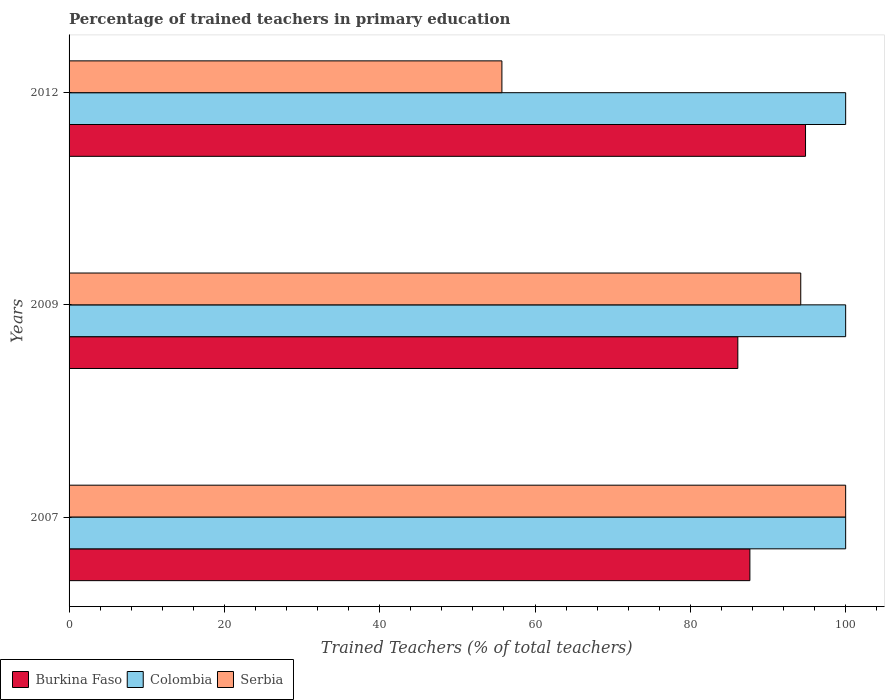Are the number of bars per tick equal to the number of legend labels?
Provide a succinct answer. Yes. How many bars are there on the 1st tick from the bottom?
Provide a succinct answer. 3. In how many cases, is the number of bars for a given year not equal to the number of legend labels?
Offer a very short reply. 0. What is the percentage of trained teachers in Serbia in 2012?
Provide a short and direct response. 55.73. Across all years, what is the minimum percentage of trained teachers in Serbia?
Offer a terse response. 55.73. In which year was the percentage of trained teachers in Burkina Faso maximum?
Offer a terse response. 2012. In which year was the percentage of trained teachers in Colombia minimum?
Make the answer very short. 2007. What is the total percentage of trained teachers in Colombia in the graph?
Make the answer very short. 300. What is the difference between the percentage of trained teachers in Colombia in 2009 and the percentage of trained teachers in Burkina Faso in 2012?
Offer a terse response. 5.17. What is the average percentage of trained teachers in Serbia per year?
Give a very brief answer. 83.32. In the year 2007, what is the difference between the percentage of trained teachers in Colombia and percentage of trained teachers in Burkina Faso?
Make the answer very short. 12.33. In how many years, is the percentage of trained teachers in Serbia greater than 52 %?
Your answer should be very brief. 3. What is the ratio of the percentage of trained teachers in Colombia in 2007 to that in 2012?
Your answer should be compact. 1. What is the difference between the highest and the second highest percentage of trained teachers in Burkina Faso?
Make the answer very short. 7.16. What is the difference between the highest and the lowest percentage of trained teachers in Colombia?
Provide a short and direct response. 0. In how many years, is the percentage of trained teachers in Burkina Faso greater than the average percentage of trained teachers in Burkina Faso taken over all years?
Keep it short and to the point. 1. What does the 1st bar from the top in 2012 represents?
Your answer should be compact. Serbia. What does the 2nd bar from the bottom in 2009 represents?
Your response must be concise. Colombia. How many bars are there?
Your answer should be compact. 9. How many years are there in the graph?
Keep it short and to the point. 3. Does the graph contain any zero values?
Your answer should be compact. No. How many legend labels are there?
Keep it short and to the point. 3. How are the legend labels stacked?
Ensure brevity in your answer.  Horizontal. What is the title of the graph?
Keep it short and to the point. Percentage of trained teachers in primary education. Does "Nepal" appear as one of the legend labels in the graph?
Offer a terse response. No. What is the label or title of the X-axis?
Your response must be concise. Trained Teachers (% of total teachers). What is the label or title of the Y-axis?
Provide a short and direct response. Years. What is the Trained Teachers (% of total teachers) in Burkina Faso in 2007?
Give a very brief answer. 87.67. What is the Trained Teachers (% of total teachers) of Serbia in 2007?
Keep it short and to the point. 100. What is the Trained Teachers (% of total teachers) of Burkina Faso in 2009?
Provide a short and direct response. 86.11. What is the Trained Teachers (% of total teachers) in Serbia in 2009?
Your response must be concise. 94.22. What is the Trained Teachers (% of total teachers) of Burkina Faso in 2012?
Your answer should be very brief. 94.83. What is the Trained Teachers (% of total teachers) of Colombia in 2012?
Keep it short and to the point. 100. What is the Trained Teachers (% of total teachers) of Serbia in 2012?
Your response must be concise. 55.73. Across all years, what is the maximum Trained Teachers (% of total teachers) in Burkina Faso?
Provide a succinct answer. 94.83. Across all years, what is the maximum Trained Teachers (% of total teachers) in Colombia?
Your answer should be compact. 100. Across all years, what is the maximum Trained Teachers (% of total teachers) of Serbia?
Ensure brevity in your answer.  100. Across all years, what is the minimum Trained Teachers (% of total teachers) in Burkina Faso?
Offer a terse response. 86.11. Across all years, what is the minimum Trained Teachers (% of total teachers) of Serbia?
Provide a short and direct response. 55.73. What is the total Trained Teachers (% of total teachers) in Burkina Faso in the graph?
Provide a succinct answer. 268.61. What is the total Trained Teachers (% of total teachers) of Colombia in the graph?
Ensure brevity in your answer.  300. What is the total Trained Teachers (% of total teachers) of Serbia in the graph?
Provide a short and direct response. 249.95. What is the difference between the Trained Teachers (% of total teachers) in Burkina Faso in 2007 and that in 2009?
Offer a terse response. 1.55. What is the difference between the Trained Teachers (% of total teachers) in Colombia in 2007 and that in 2009?
Your answer should be compact. 0. What is the difference between the Trained Teachers (% of total teachers) in Serbia in 2007 and that in 2009?
Your response must be concise. 5.78. What is the difference between the Trained Teachers (% of total teachers) in Burkina Faso in 2007 and that in 2012?
Your answer should be compact. -7.16. What is the difference between the Trained Teachers (% of total teachers) in Serbia in 2007 and that in 2012?
Provide a succinct answer. 44.27. What is the difference between the Trained Teachers (% of total teachers) of Burkina Faso in 2009 and that in 2012?
Make the answer very short. -8.72. What is the difference between the Trained Teachers (% of total teachers) of Serbia in 2009 and that in 2012?
Your response must be concise. 38.48. What is the difference between the Trained Teachers (% of total teachers) in Burkina Faso in 2007 and the Trained Teachers (% of total teachers) in Colombia in 2009?
Make the answer very short. -12.33. What is the difference between the Trained Teachers (% of total teachers) of Burkina Faso in 2007 and the Trained Teachers (% of total teachers) of Serbia in 2009?
Make the answer very short. -6.55. What is the difference between the Trained Teachers (% of total teachers) of Colombia in 2007 and the Trained Teachers (% of total teachers) of Serbia in 2009?
Offer a very short reply. 5.78. What is the difference between the Trained Teachers (% of total teachers) of Burkina Faso in 2007 and the Trained Teachers (% of total teachers) of Colombia in 2012?
Offer a very short reply. -12.33. What is the difference between the Trained Teachers (% of total teachers) in Burkina Faso in 2007 and the Trained Teachers (% of total teachers) in Serbia in 2012?
Ensure brevity in your answer.  31.93. What is the difference between the Trained Teachers (% of total teachers) of Colombia in 2007 and the Trained Teachers (% of total teachers) of Serbia in 2012?
Your answer should be very brief. 44.27. What is the difference between the Trained Teachers (% of total teachers) in Burkina Faso in 2009 and the Trained Teachers (% of total teachers) in Colombia in 2012?
Keep it short and to the point. -13.89. What is the difference between the Trained Teachers (% of total teachers) in Burkina Faso in 2009 and the Trained Teachers (% of total teachers) in Serbia in 2012?
Make the answer very short. 30.38. What is the difference between the Trained Teachers (% of total teachers) of Colombia in 2009 and the Trained Teachers (% of total teachers) of Serbia in 2012?
Your answer should be very brief. 44.27. What is the average Trained Teachers (% of total teachers) in Burkina Faso per year?
Ensure brevity in your answer.  89.54. What is the average Trained Teachers (% of total teachers) in Colombia per year?
Provide a short and direct response. 100. What is the average Trained Teachers (% of total teachers) in Serbia per year?
Offer a very short reply. 83.32. In the year 2007, what is the difference between the Trained Teachers (% of total teachers) of Burkina Faso and Trained Teachers (% of total teachers) of Colombia?
Your answer should be very brief. -12.33. In the year 2007, what is the difference between the Trained Teachers (% of total teachers) in Burkina Faso and Trained Teachers (% of total teachers) in Serbia?
Your answer should be compact. -12.33. In the year 2007, what is the difference between the Trained Teachers (% of total teachers) in Colombia and Trained Teachers (% of total teachers) in Serbia?
Your response must be concise. 0. In the year 2009, what is the difference between the Trained Teachers (% of total teachers) in Burkina Faso and Trained Teachers (% of total teachers) in Colombia?
Give a very brief answer. -13.89. In the year 2009, what is the difference between the Trained Teachers (% of total teachers) of Burkina Faso and Trained Teachers (% of total teachers) of Serbia?
Your answer should be compact. -8.1. In the year 2009, what is the difference between the Trained Teachers (% of total teachers) in Colombia and Trained Teachers (% of total teachers) in Serbia?
Your answer should be compact. 5.78. In the year 2012, what is the difference between the Trained Teachers (% of total teachers) of Burkina Faso and Trained Teachers (% of total teachers) of Colombia?
Ensure brevity in your answer.  -5.17. In the year 2012, what is the difference between the Trained Teachers (% of total teachers) in Burkina Faso and Trained Teachers (% of total teachers) in Serbia?
Your answer should be very brief. 39.1. In the year 2012, what is the difference between the Trained Teachers (% of total teachers) of Colombia and Trained Teachers (% of total teachers) of Serbia?
Your answer should be very brief. 44.27. What is the ratio of the Trained Teachers (% of total teachers) of Serbia in 2007 to that in 2009?
Make the answer very short. 1.06. What is the ratio of the Trained Teachers (% of total teachers) in Burkina Faso in 2007 to that in 2012?
Your response must be concise. 0.92. What is the ratio of the Trained Teachers (% of total teachers) of Serbia in 2007 to that in 2012?
Your answer should be very brief. 1.79. What is the ratio of the Trained Teachers (% of total teachers) of Burkina Faso in 2009 to that in 2012?
Your answer should be compact. 0.91. What is the ratio of the Trained Teachers (% of total teachers) of Colombia in 2009 to that in 2012?
Your answer should be compact. 1. What is the ratio of the Trained Teachers (% of total teachers) in Serbia in 2009 to that in 2012?
Your response must be concise. 1.69. What is the difference between the highest and the second highest Trained Teachers (% of total teachers) in Burkina Faso?
Give a very brief answer. 7.16. What is the difference between the highest and the second highest Trained Teachers (% of total teachers) of Colombia?
Ensure brevity in your answer.  0. What is the difference between the highest and the second highest Trained Teachers (% of total teachers) of Serbia?
Give a very brief answer. 5.78. What is the difference between the highest and the lowest Trained Teachers (% of total teachers) in Burkina Faso?
Offer a very short reply. 8.72. What is the difference between the highest and the lowest Trained Teachers (% of total teachers) in Colombia?
Give a very brief answer. 0. What is the difference between the highest and the lowest Trained Teachers (% of total teachers) in Serbia?
Ensure brevity in your answer.  44.27. 